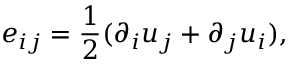<formula> <loc_0><loc_0><loc_500><loc_500>e _ { i j } = \frac { 1 } { 2 } ( \partial _ { i } u _ { j } + \partial _ { j } u _ { i } ) ,</formula> 